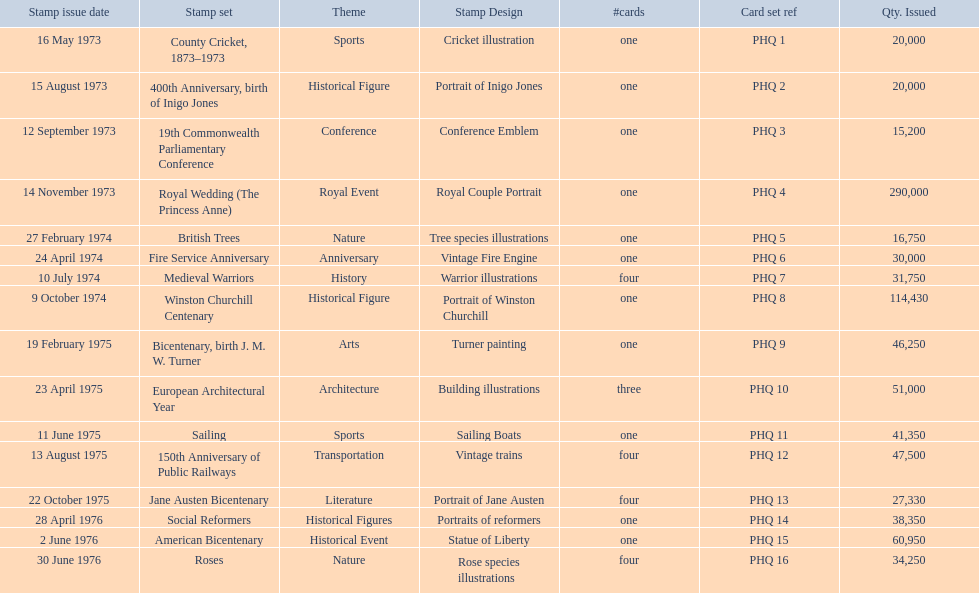Which stamp sets contained more than one card? Medieval Warriors, European Architectural Year, 150th Anniversary of Public Railways, Jane Austen Bicentenary, Roses. Of those stamp sets, which contains a unique number of cards? European Architectural Year. 